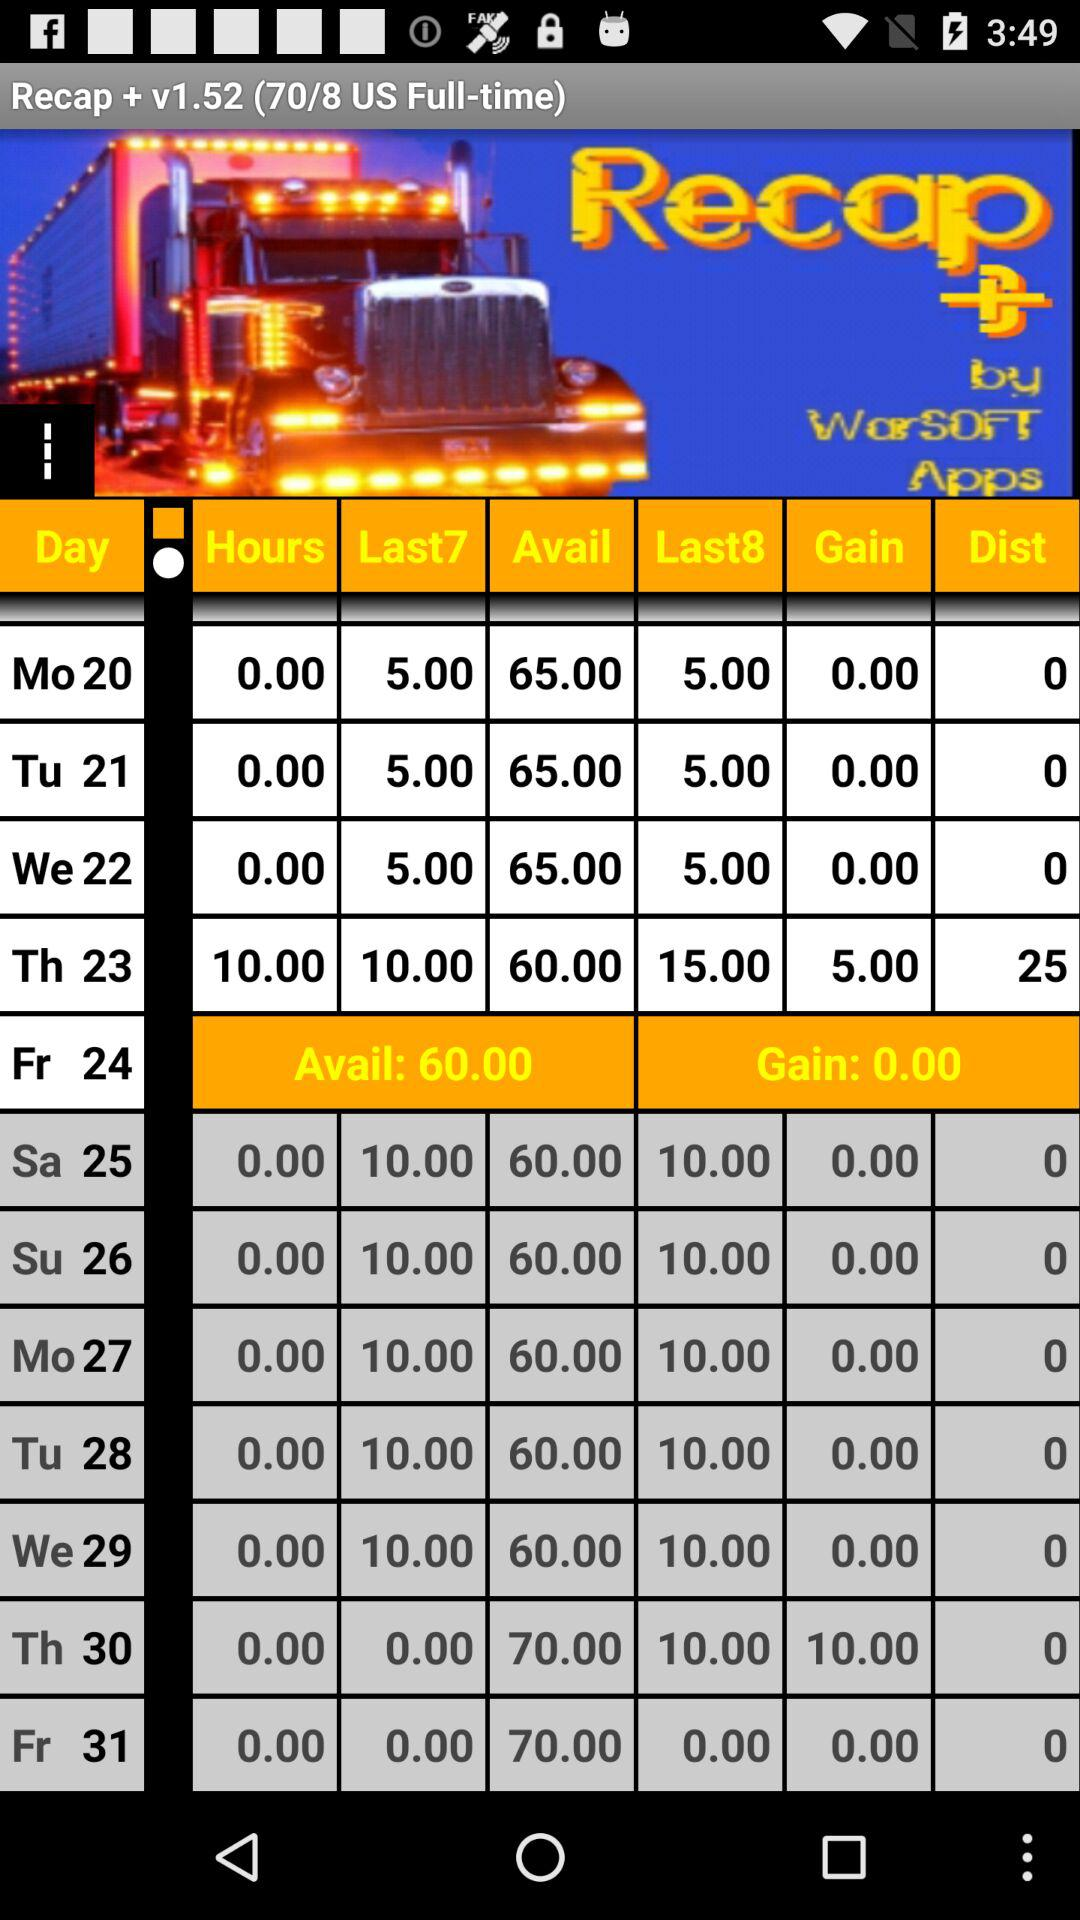What is the "Gain" on the 24th? The "Gain" on the 24th is 0. 